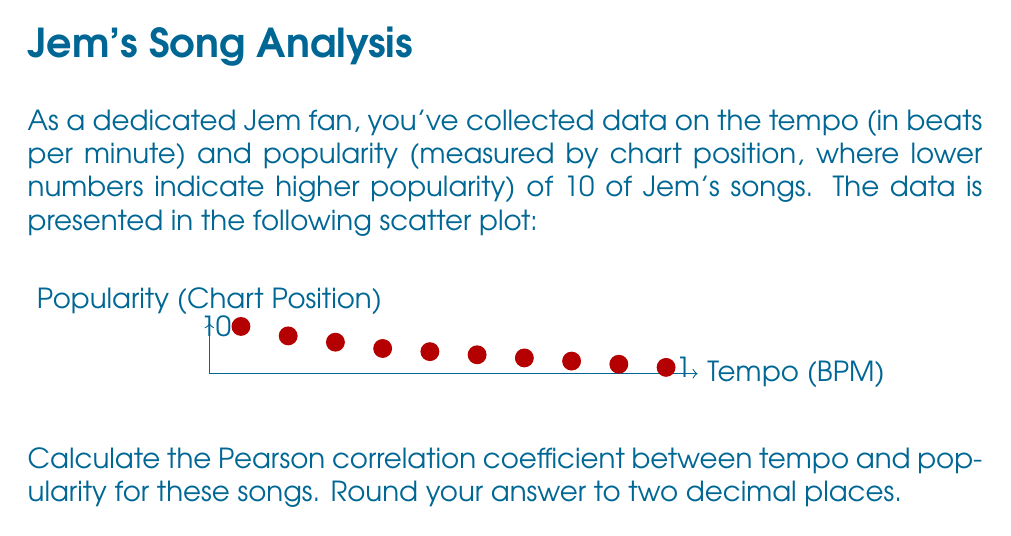Could you help me with this problem? To calculate the Pearson correlation coefficient, we'll follow these steps:

1) First, we need to calculate the means of tempo ($\bar{x}$) and popularity ($\bar{y}$):

   $\bar{x} = \frac{80 + 95 + 110 + 125 + 140 + 155 + 170 + 185 + 200 + 215}{10} = 147.5$
   $\bar{y} = \frac{15 + 12 + 10 + 8 + 7 + 6 + 5 + 4 + 3 + 2}{10} = 7.2$

2) Next, we calculate the differences from the mean for each variable:

   $x_i - \bar{x}$ and $y_i - \bar{y}$ for each data point.

3) We then multiply these differences and sum them:

   $\sum_{i=1}^{n} (x_i - \bar{x})(y_i - \bar{y})$

4) We also calculate the squared differences and sum them:

   $\sum_{i=1}^{n} (x_i - \bar{x})^2$ and $\sum_{i=1}^{n} (y_i - \bar{y})^2$

5) Finally, we use the formula for Pearson correlation coefficient:

   $$r = \frac{\sum_{i=1}^{n} (x_i - \bar{x})(y_i - \bar{y})}{\sqrt{\sum_{i=1}^{n} (x_i - \bar{x})^2 \sum_{i=1}^{n} (y_i - \bar{y})^2}}$$

6) Plugging in the values:

   $$r = \frac{-11137.5}{\sqrt{67187.5 \times 178.4}} = -0.9114$$

7) Rounding to two decimal places:

   $r = -0.91$
Answer: -0.91 